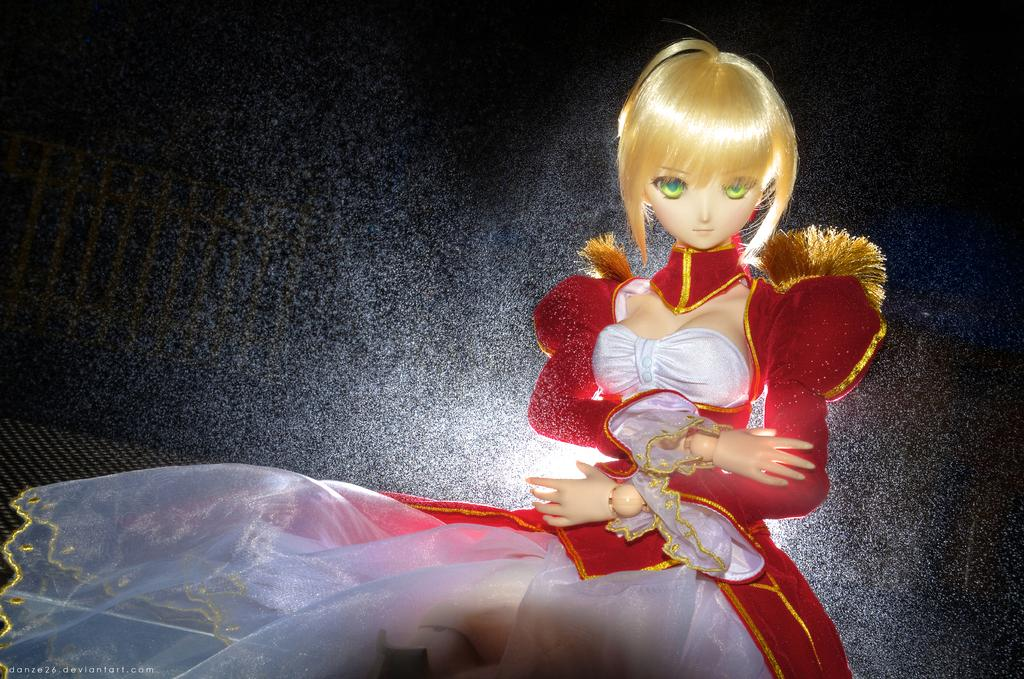What is the main subject of the image? There is a doll in the image. What color is the doll? The doll is cream in color. What is the doll wearing? The doll is wearing a red and white colored dress. What can be seen in the background of the image? The background of the image is black. What organization is the doll affiliated with in the image? There is no indication in the image that the doll is affiliated with any organization. How does the doll move in the image? The doll is not moving in the image; it is stationary. 